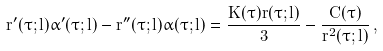Convert formula to latex. <formula><loc_0><loc_0><loc_500><loc_500>r ^ { \prime } ( \tau ; l ) \alpha ^ { \prime } ( \tau ; l ) - r ^ { \prime \prime } ( \tau ; l ) \alpha ( \tau ; l ) = \frac { \dot { K } ( \tau ) r ( \tau ; l ) } { 3 } - \frac { \dot { C } ( \tau ) } { r ^ { 2 } ( \tau ; l ) } \, ,</formula> 